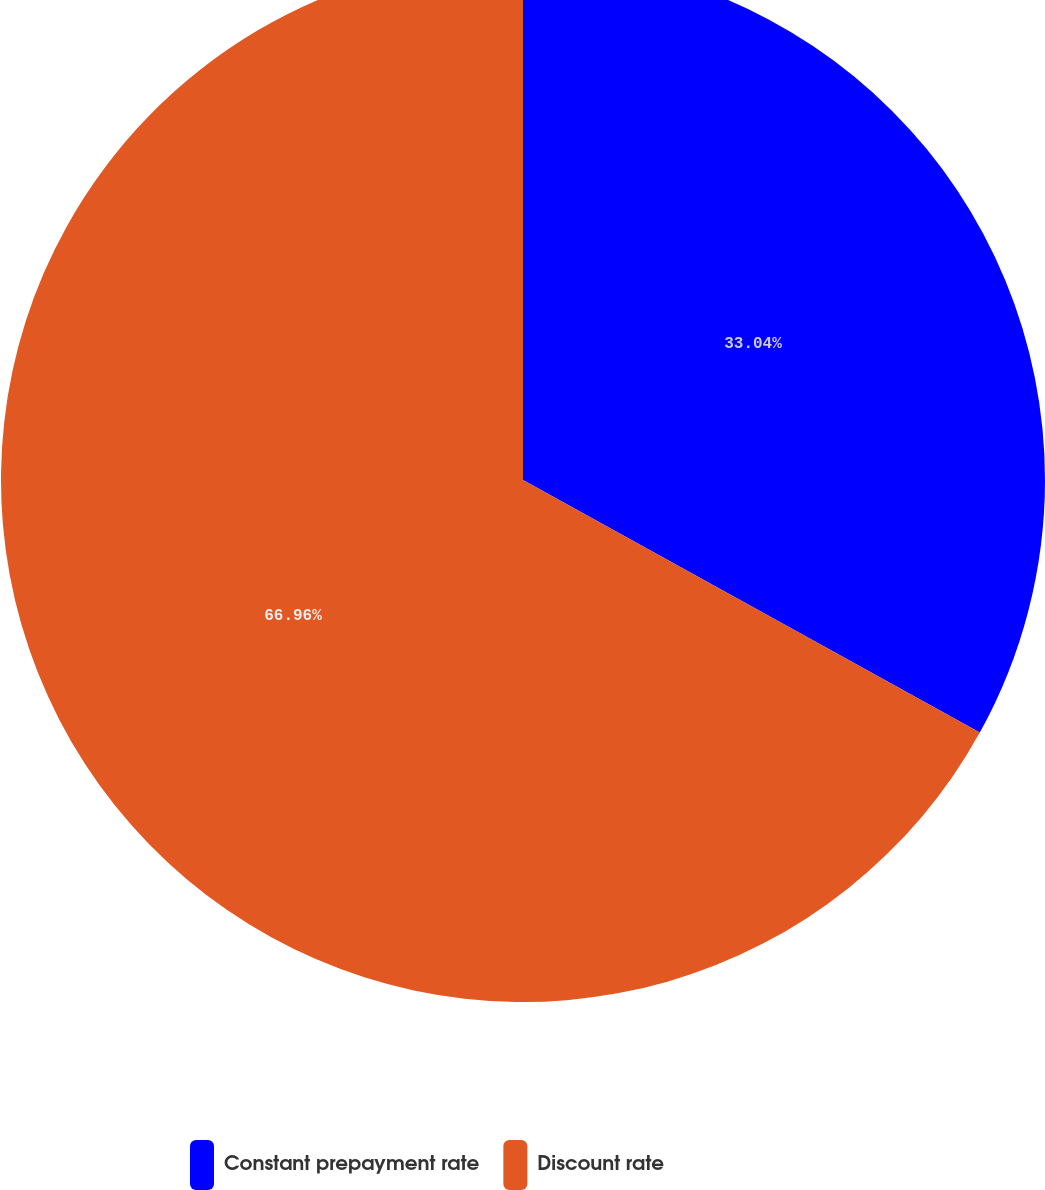Convert chart. <chart><loc_0><loc_0><loc_500><loc_500><pie_chart><fcel>Constant prepayment rate<fcel>Discount rate<nl><fcel>33.04%<fcel>66.96%<nl></chart> 